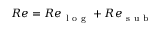Convert formula to latex. <formula><loc_0><loc_0><loc_500><loc_500>R e = R e _ { l o g } + R e _ { s u b }</formula> 